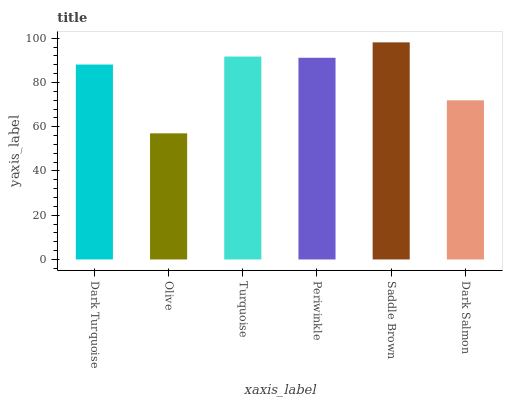Is Olive the minimum?
Answer yes or no. Yes. Is Saddle Brown the maximum?
Answer yes or no. Yes. Is Turquoise the minimum?
Answer yes or no. No. Is Turquoise the maximum?
Answer yes or no. No. Is Turquoise greater than Olive?
Answer yes or no. Yes. Is Olive less than Turquoise?
Answer yes or no. Yes. Is Olive greater than Turquoise?
Answer yes or no. No. Is Turquoise less than Olive?
Answer yes or no. No. Is Periwinkle the high median?
Answer yes or no. Yes. Is Dark Turquoise the low median?
Answer yes or no. Yes. Is Saddle Brown the high median?
Answer yes or no. No. Is Saddle Brown the low median?
Answer yes or no. No. 